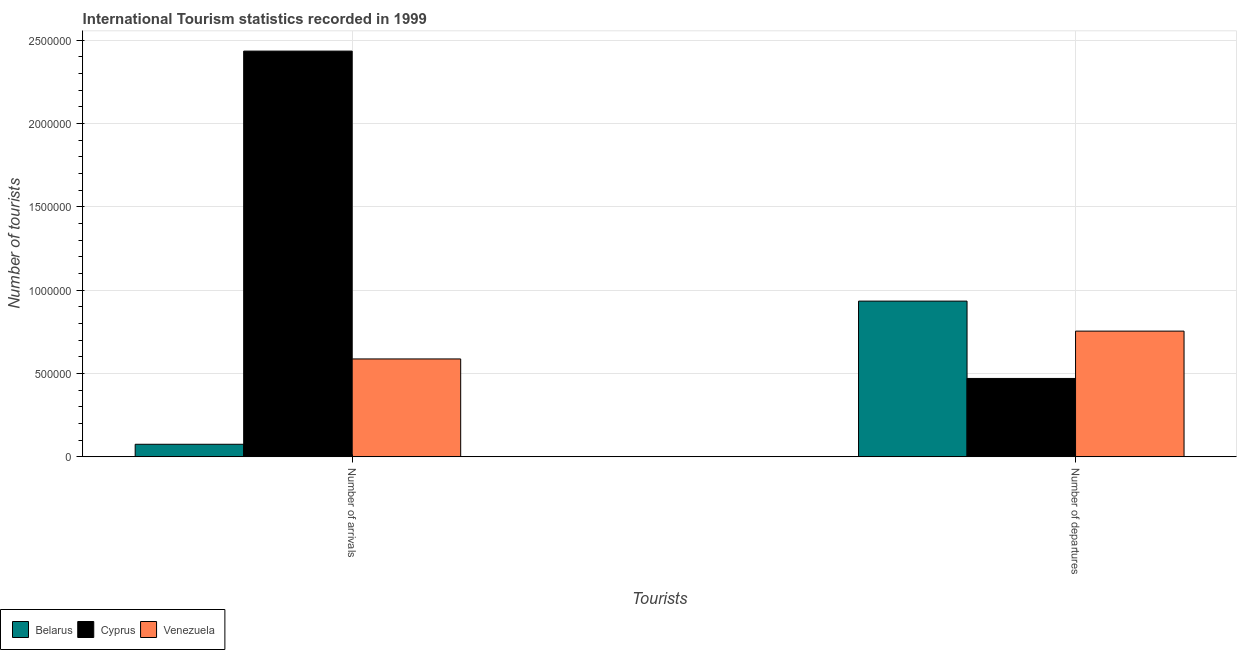How many different coloured bars are there?
Offer a very short reply. 3. How many groups of bars are there?
Provide a short and direct response. 2. How many bars are there on the 2nd tick from the left?
Keep it short and to the point. 3. What is the label of the 2nd group of bars from the left?
Keep it short and to the point. Number of departures. What is the number of tourist departures in Venezuela?
Give a very brief answer. 7.54e+05. Across all countries, what is the maximum number of tourist departures?
Provide a succinct answer. 9.34e+05. Across all countries, what is the minimum number of tourist arrivals?
Give a very brief answer. 7.50e+04. In which country was the number of tourist departures maximum?
Offer a terse response. Belarus. In which country was the number of tourist arrivals minimum?
Your answer should be very brief. Belarus. What is the total number of tourist arrivals in the graph?
Give a very brief answer. 3.10e+06. What is the difference between the number of tourist arrivals in Cyprus and that in Belarus?
Give a very brief answer. 2.36e+06. What is the difference between the number of tourist arrivals in Cyprus and the number of tourist departures in Belarus?
Provide a short and direct response. 1.50e+06. What is the average number of tourist arrivals per country?
Offer a terse response. 1.03e+06. What is the difference between the number of tourist arrivals and number of tourist departures in Cyprus?
Ensure brevity in your answer.  1.96e+06. What is the ratio of the number of tourist arrivals in Cyprus to that in Belarus?
Offer a terse response. 32.45. What does the 1st bar from the left in Number of arrivals represents?
Keep it short and to the point. Belarus. What does the 1st bar from the right in Number of departures represents?
Keep it short and to the point. Venezuela. How many countries are there in the graph?
Provide a succinct answer. 3. Are the values on the major ticks of Y-axis written in scientific E-notation?
Your response must be concise. No. Where does the legend appear in the graph?
Your response must be concise. Bottom left. How many legend labels are there?
Give a very brief answer. 3. How are the legend labels stacked?
Provide a succinct answer. Horizontal. What is the title of the graph?
Your response must be concise. International Tourism statistics recorded in 1999. What is the label or title of the X-axis?
Provide a succinct answer. Tourists. What is the label or title of the Y-axis?
Ensure brevity in your answer.  Number of tourists. What is the Number of tourists in Belarus in Number of arrivals?
Your response must be concise. 7.50e+04. What is the Number of tourists in Cyprus in Number of arrivals?
Keep it short and to the point. 2.43e+06. What is the Number of tourists in Venezuela in Number of arrivals?
Offer a very short reply. 5.87e+05. What is the Number of tourists of Belarus in Number of departures?
Ensure brevity in your answer.  9.34e+05. What is the Number of tourists in Venezuela in Number of departures?
Make the answer very short. 7.54e+05. Across all Tourists, what is the maximum Number of tourists in Belarus?
Your answer should be compact. 9.34e+05. Across all Tourists, what is the maximum Number of tourists in Cyprus?
Your answer should be compact. 2.43e+06. Across all Tourists, what is the maximum Number of tourists of Venezuela?
Provide a succinct answer. 7.54e+05. Across all Tourists, what is the minimum Number of tourists in Belarus?
Give a very brief answer. 7.50e+04. Across all Tourists, what is the minimum Number of tourists in Venezuela?
Ensure brevity in your answer.  5.87e+05. What is the total Number of tourists of Belarus in the graph?
Provide a short and direct response. 1.01e+06. What is the total Number of tourists in Cyprus in the graph?
Offer a terse response. 2.90e+06. What is the total Number of tourists in Venezuela in the graph?
Offer a terse response. 1.34e+06. What is the difference between the Number of tourists in Belarus in Number of arrivals and that in Number of departures?
Your response must be concise. -8.59e+05. What is the difference between the Number of tourists of Cyprus in Number of arrivals and that in Number of departures?
Ensure brevity in your answer.  1.96e+06. What is the difference between the Number of tourists of Venezuela in Number of arrivals and that in Number of departures?
Your answer should be very brief. -1.67e+05. What is the difference between the Number of tourists of Belarus in Number of arrivals and the Number of tourists of Cyprus in Number of departures?
Provide a short and direct response. -3.95e+05. What is the difference between the Number of tourists of Belarus in Number of arrivals and the Number of tourists of Venezuela in Number of departures?
Provide a short and direct response. -6.79e+05. What is the difference between the Number of tourists in Cyprus in Number of arrivals and the Number of tourists in Venezuela in Number of departures?
Offer a terse response. 1.68e+06. What is the average Number of tourists in Belarus per Tourists?
Provide a short and direct response. 5.04e+05. What is the average Number of tourists of Cyprus per Tourists?
Your answer should be compact. 1.45e+06. What is the average Number of tourists in Venezuela per Tourists?
Make the answer very short. 6.70e+05. What is the difference between the Number of tourists of Belarus and Number of tourists of Cyprus in Number of arrivals?
Offer a terse response. -2.36e+06. What is the difference between the Number of tourists of Belarus and Number of tourists of Venezuela in Number of arrivals?
Provide a succinct answer. -5.12e+05. What is the difference between the Number of tourists of Cyprus and Number of tourists of Venezuela in Number of arrivals?
Your answer should be very brief. 1.85e+06. What is the difference between the Number of tourists of Belarus and Number of tourists of Cyprus in Number of departures?
Ensure brevity in your answer.  4.64e+05. What is the difference between the Number of tourists in Belarus and Number of tourists in Venezuela in Number of departures?
Make the answer very short. 1.80e+05. What is the difference between the Number of tourists in Cyprus and Number of tourists in Venezuela in Number of departures?
Your answer should be compact. -2.84e+05. What is the ratio of the Number of tourists in Belarus in Number of arrivals to that in Number of departures?
Keep it short and to the point. 0.08. What is the ratio of the Number of tourists in Cyprus in Number of arrivals to that in Number of departures?
Provide a short and direct response. 5.18. What is the ratio of the Number of tourists of Venezuela in Number of arrivals to that in Number of departures?
Make the answer very short. 0.78. What is the difference between the highest and the second highest Number of tourists of Belarus?
Make the answer very short. 8.59e+05. What is the difference between the highest and the second highest Number of tourists of Cyprus?
Your response must be concise. 1.96e+06. What is the difference between the highest and the second highest Number of tourists in Venezuela?
Ensure brevity in your answer.  1.67e+05. What is the difference between the highest and the lowest Number of tourists of Belarus?
Provide a short and direct response. 8.59e+05. What is the difference between the highest and the lowest Number of tourists of Cyprus?
Keep it short and to the point. 1.96e+06. What is the difference between the highest and the lowest Number of tourists of Venezuela?
Make the answer very short. 1.67e+05. 